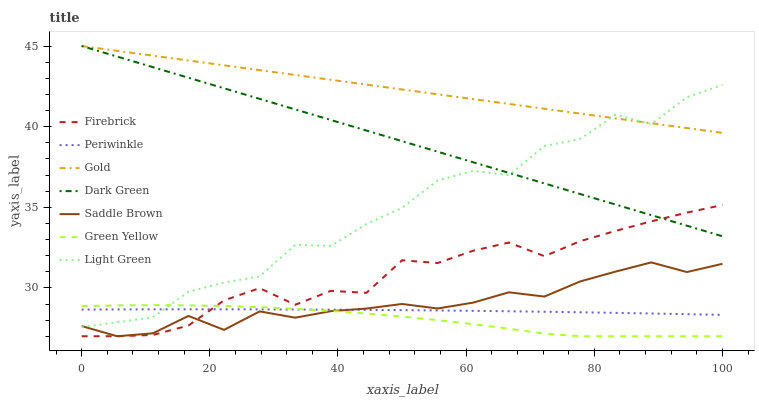Does Green Yellow have the minimum area under the curve?
Answer yes or no. Yes. Does Gold have the maximum area under the curve?
Answer yes or no. Yes. Does Firebrick have the minimum area under the curve?
Answer yes or no. No. Does Firebrick have the maximum area under the curve?
Answer yes or no. No. Is Gold the smoothest?
Answer yes or no. Yes. Is Light Green the roughest?
Answer yes or no. Yes. Is Firebrick the smoothest?
Answer yes or no. No. Is Firebrick the roughest?
Answer yes or no. No. Does Firebrick have the lowest value?
Answer yes or no. Yes. Does Periwinkle have the lowest value?
Answer yes or no. No. Does Dark Green have the highest value?
Answer yes or no. Yes. Does Firebrick have the highest value?
Answer yes or no. No. Is Saddle Brown less than Dark Green?
Answer yes or no. Yes. Is Dark Green greater than Periwinkle?
Answer yes or no. Yes. Does Firebrick intersect Saddle Brown?
Answer yes or no. Yes. Is Firebrick less than Saddle Brown?
Answer yes or no. No. Is Firebrick greater than Saddle Brown?
Answer yes or no. No. Does Saddle Brown intersect Dark Green?
Answer yes or no. No. 